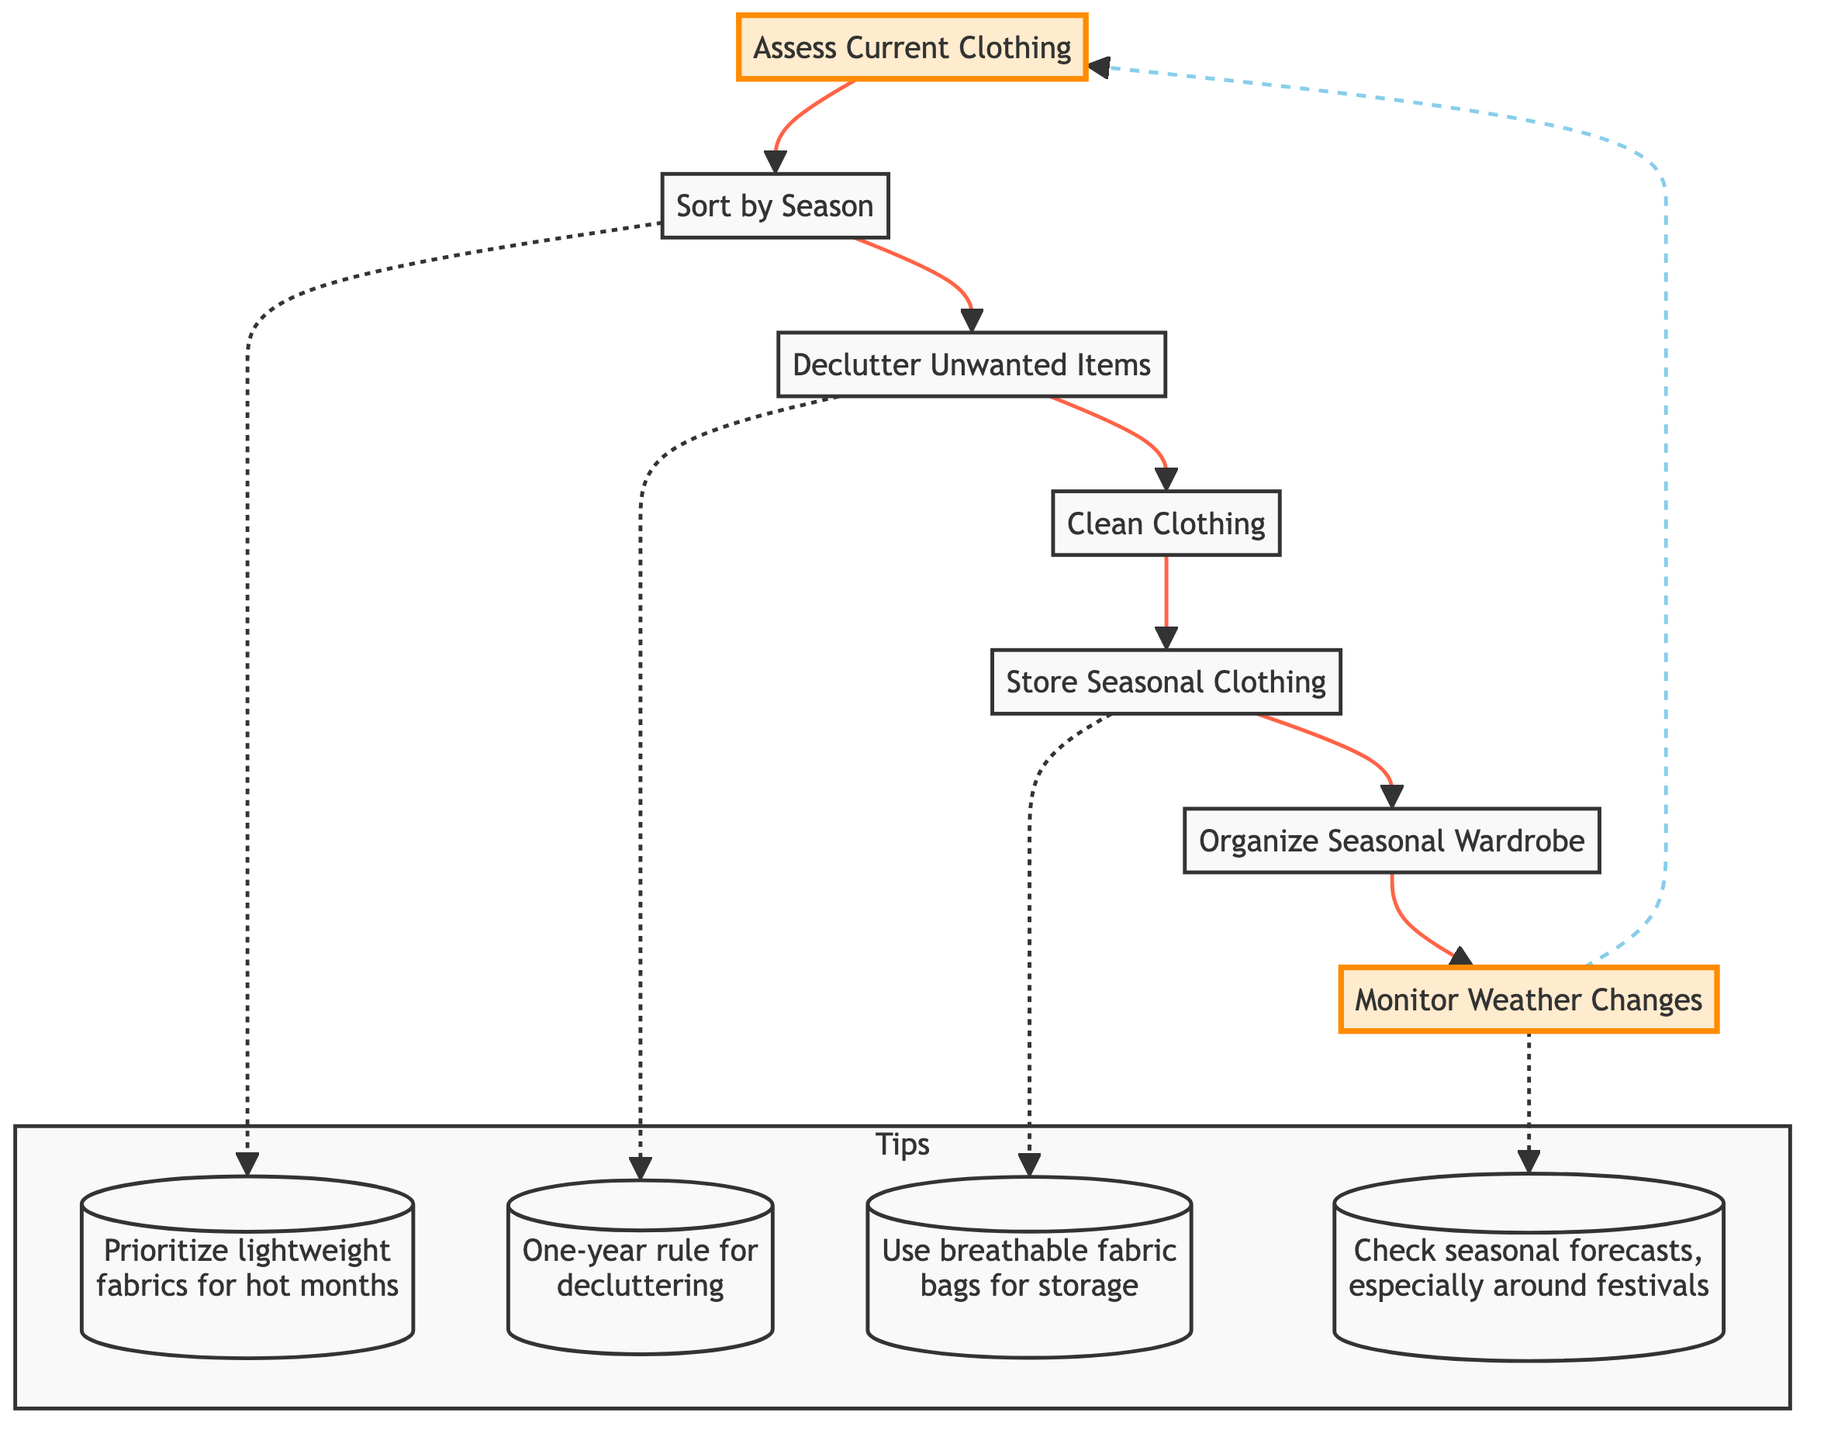What is the first step in the diagram? The diagram starts with the step titled "Assess Current Clothing," which is shown as the initial node connected to "Sort by Season."
Answer: Assess Current Clothing How many main steps are there in total? The diagram contains a total of seven main steps, starting from assessing clothing and ending with monitoring weather changes.
Answer: 7 What step comes after "Declutter Unwanted Items"? After the "Declutter Unwanted Items" step, the next step is "Clean Clothing," as indicated by the directed arrow in the flow.
Answer: Clean Clothing Which tip is associated with the "Sort by Season" step? The tip connected to the "Sort by Season" step emphasizes using lightweight fabrics for hot months, which is shown in the tips subgraph.
Answer: Prioritize lightweight fabrics for hot months What is the last step of the flow chart? The last step in the flow chart is "Monitor Weather Changes," which loops back to "Assess Current Clothing," indicating a continuous cycle.
Answer: Monitor Weather Changes Which step is linked to the tip about checking seasonal forecasts? The tip regarding checking seasonal forecasts is associated with the "Monitor Weather Changes" step, highlighting the importance of weather awareness.
Answer: Monitor Weather Changes 